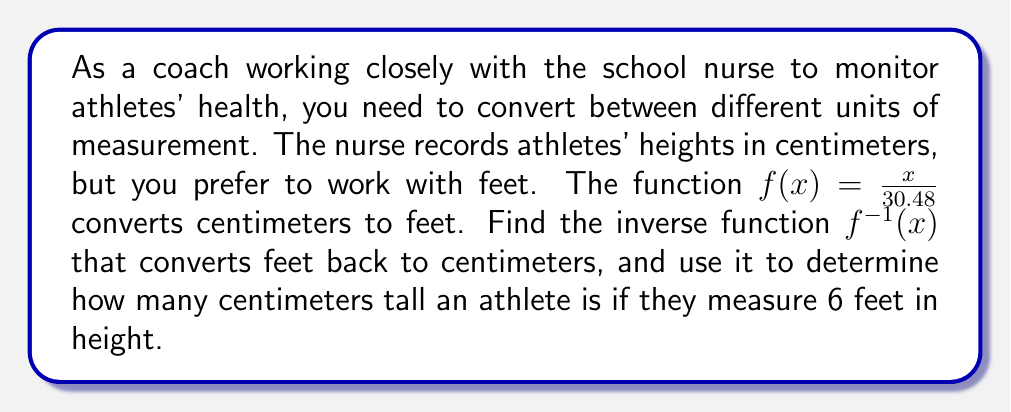Can you answer this question? To find the inverse function, we follow these steps:

1) Start with the original function: $f(x) = \frac{x}{30.48}$

2) Replace $f(x)$ with $y$: $y = \frac{x}{30.48}$

3) Swap $x$ and $y$: $x = \frac{y}{30.48}$

4) Solve for $y$:
   $x = \frac{y}{30.48}$
   $x \cdot 30.48 = y$
   $y = 30.48x$

5) Replace $y$ with $f^{-1}(x)$: $f^{-1}(x) = 30.48x$

Now that we have the inverse function, we can use it to convert 6 feet to centimeters:

$f^{-1}(6) = 30.48 \cdot 6 = 182.88$

Therefore, an athlete who is 6 feet tall measures 182.88 centimeters in height.
Answer: The inverse function is $f^{-1}(x) = 30.48x$, and an athlete who is 6 feet tall measures 182.88 centimeters. 